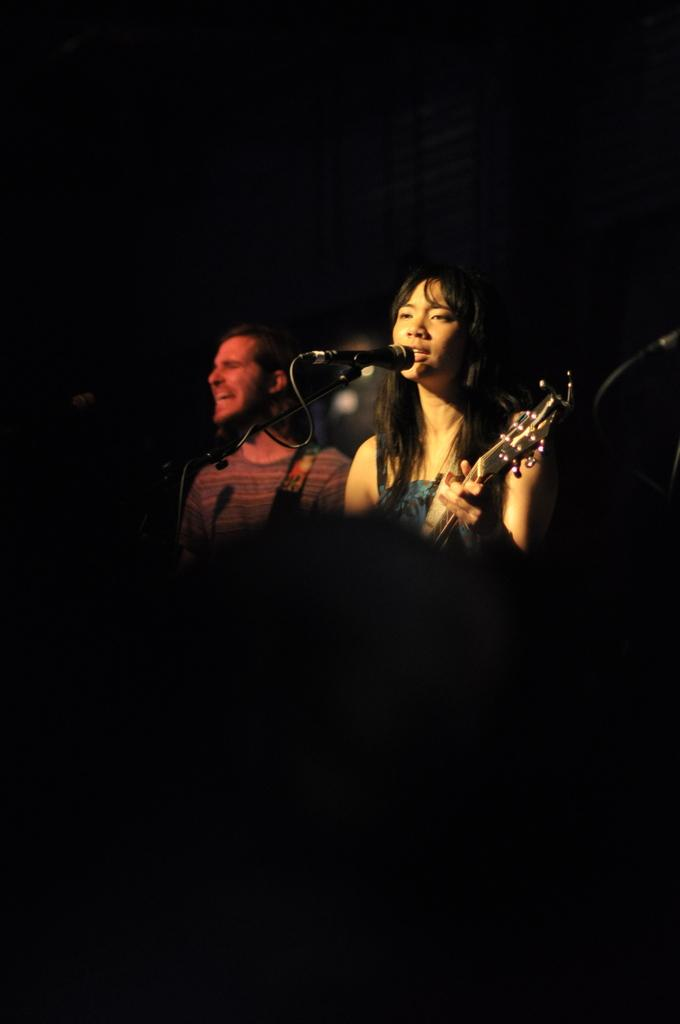How many people are in the image? There are a few people in the image. What is one person doing in the image? One person is holding an object. What can be seen in the image that is used for amplifying sound? There are microphones visible in the image. What is the color of the background in the image? The background of the image is dark. What type of vegetable is being used as a prop by the person holding an object in the image? There is no vegetable present in the image; the person is holding an unspecified object. Can you tell me how many parents are visible in the image? There is no reference to parents in the image, so it's not possible to determine how many might be present. 